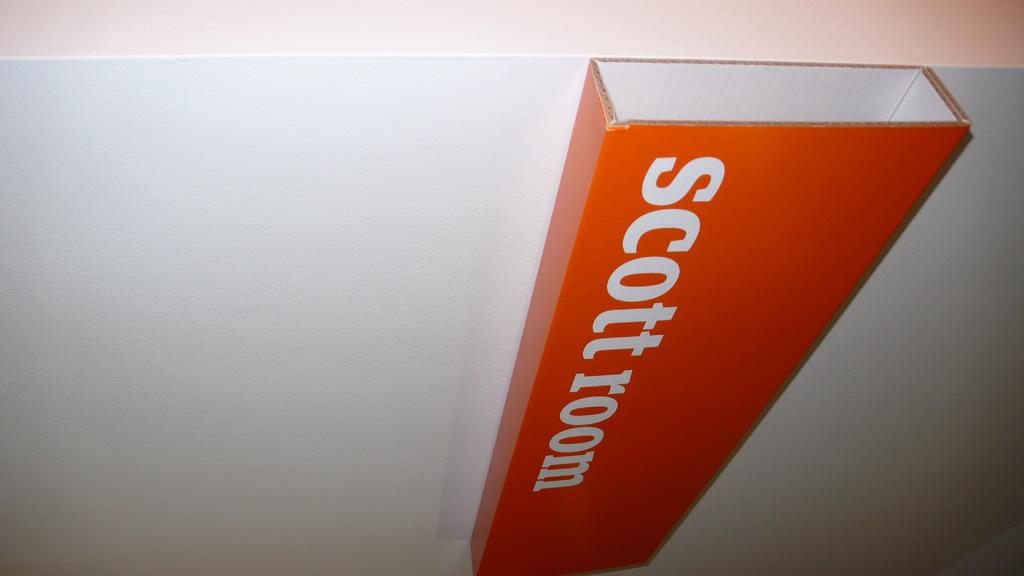<image>
Create a compact narrative representing the image presented. A white background with a red rectangle texture coming out of it with signaling its scottroom. 